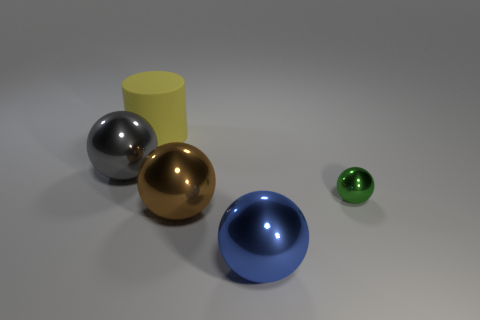What number of other objects are the same material as the cylinder?
Give a very brief answer. 0. Is the cylinder that is behind the small green sphere made of the same material as the big blue thing?
Your answer should be very brief. No. There is a metallic object that is behind the object to the right of the large shiny object that is in front of the big brown metal sphere; how big is it?
Offer a very short reply. Large. What shape is the blue metal object that is the same size as the gray sphere?
Keep it short and to the point. Sphere. There is a shiny thing that is to the right of the blue ball; what is its size?
Provide a short and direct response. Small. What is the large object that is behind the sphere behind the shiny sphere on the right side of the blue shiny object made of?
Keep it short and to the point. Rubber. Is there a blue metallic sphere of the same size as the yellow object?
Provide a short and direct response. Yes. What material is the blue ball that is the same size as the brown metal object?
Your answer should be very brief. Metal. There is a large yellow rubber thing on the left side of the tiny sphere; what shape is it?
Your answer should be compact. Cylinder. Is the material of the thing to the right of the blue metal ball the same as the thing that is behind the large gray shiny ball?
Give a very brief answer. No. 